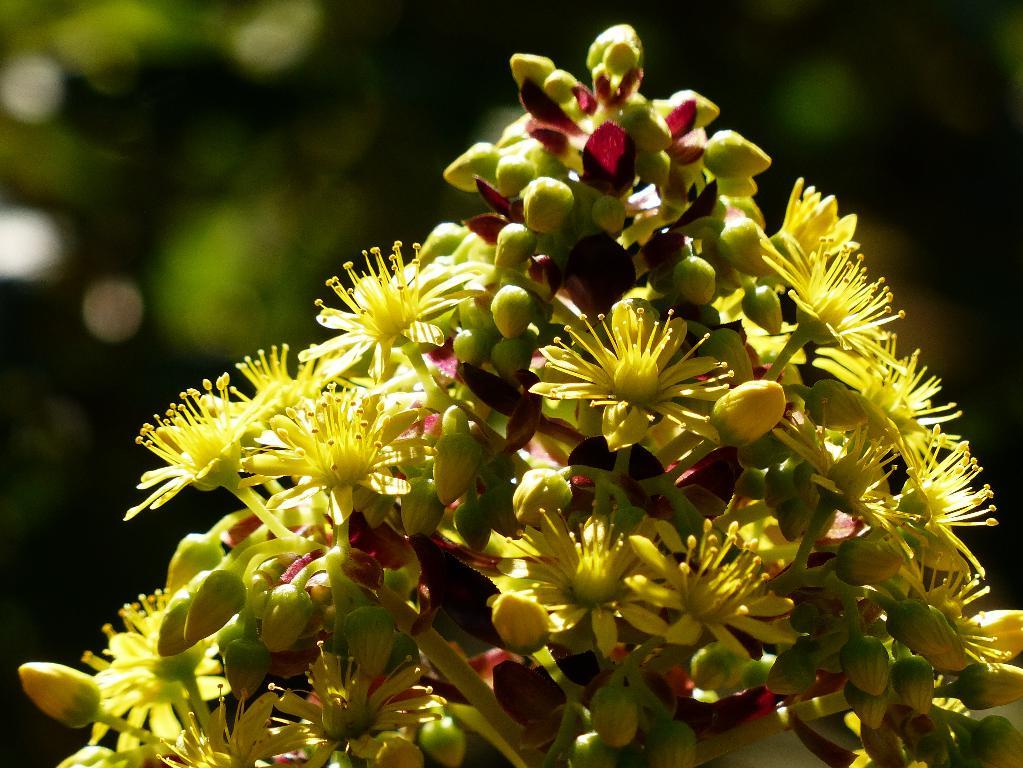What type of plants can be seen in the image? There are flowers in the image. Can you describe the background of the image? The background of the image is blurred. How many chairs are visible in the image? There are no chairs present in the image; it only features flowers and a blurred background. 